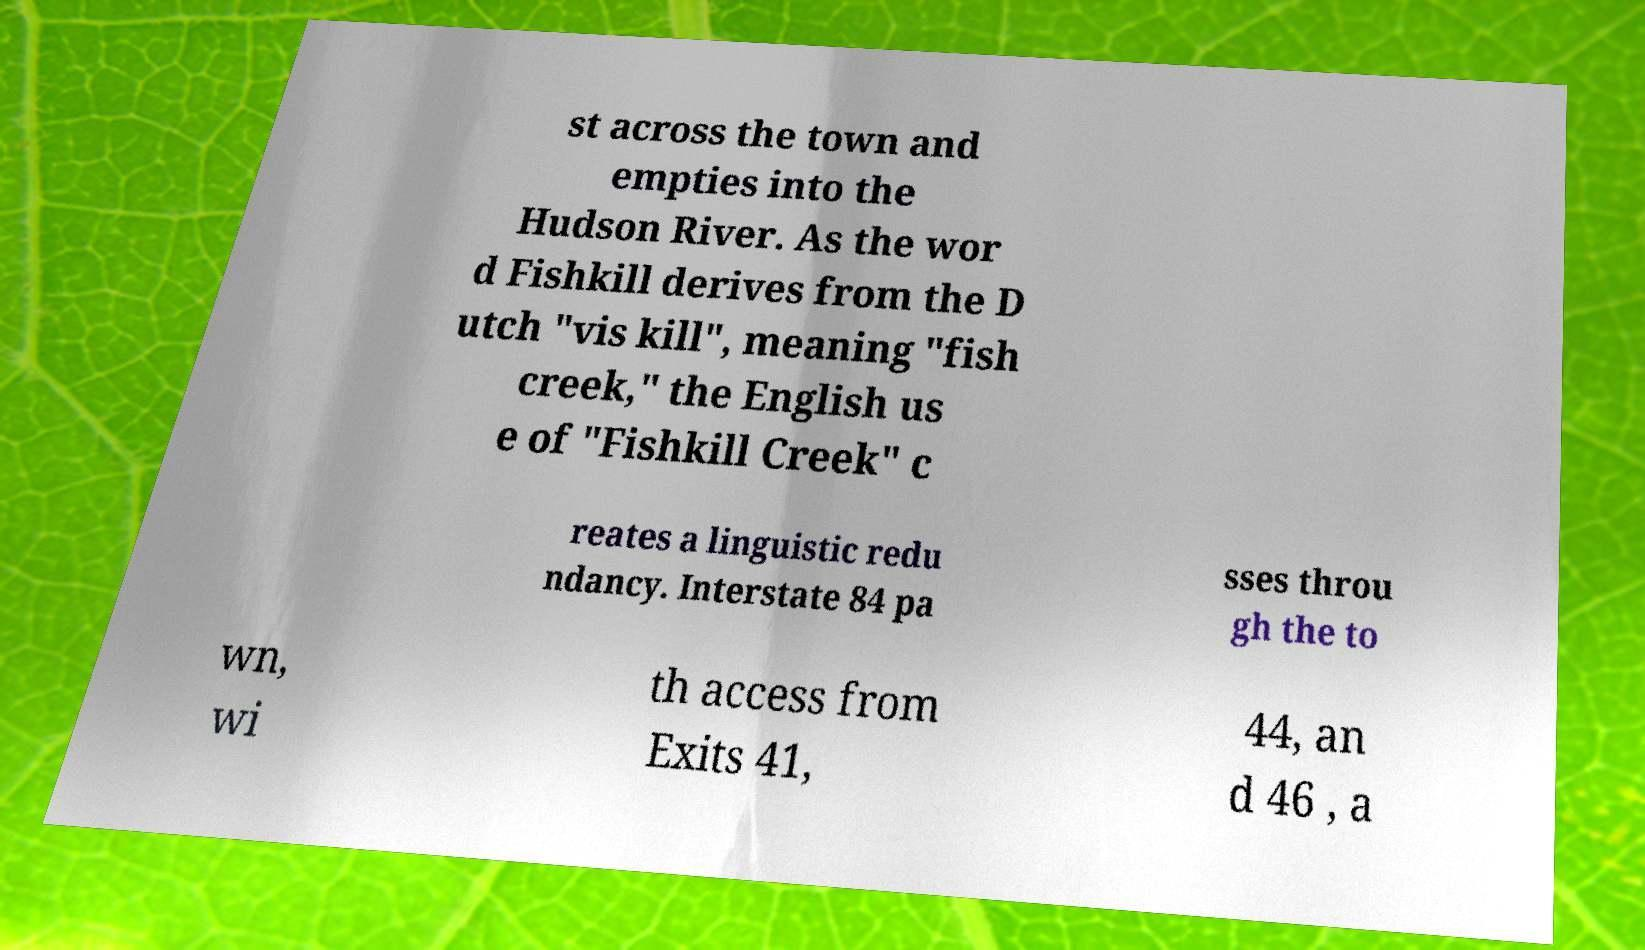Could you extract and type out the text from this image? st across the town and empties into the Hudson River. As the wor d Fishkill derives from the D utch "vis kill", meaning "fish creek," the English us e of "Fishkill Creek" c reates a linguistic redu ndancy. Interstate 84 pa sses throu gh the to wn, wi th access from Exits 41, 44, an d 46 , a 